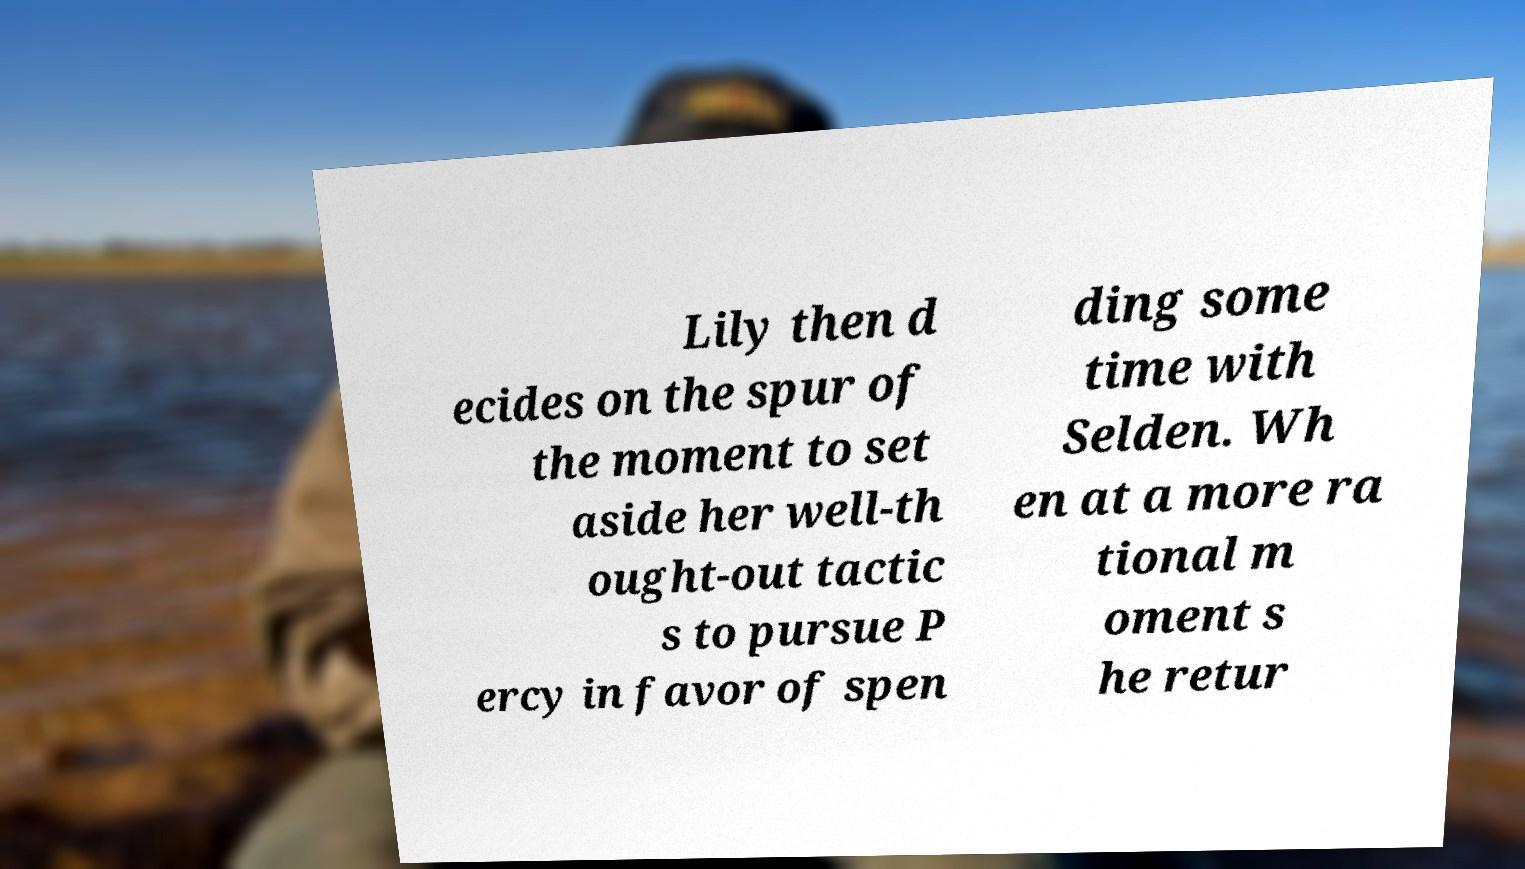Please identify and transcribe the text found in this image. Lily then d ecides on the spur of the moment to set aside her well-th ought-out tactic s to pursue P ercy in favor of spen ding some time with Selden. Wh en at a more ra tional m oment s he retur 